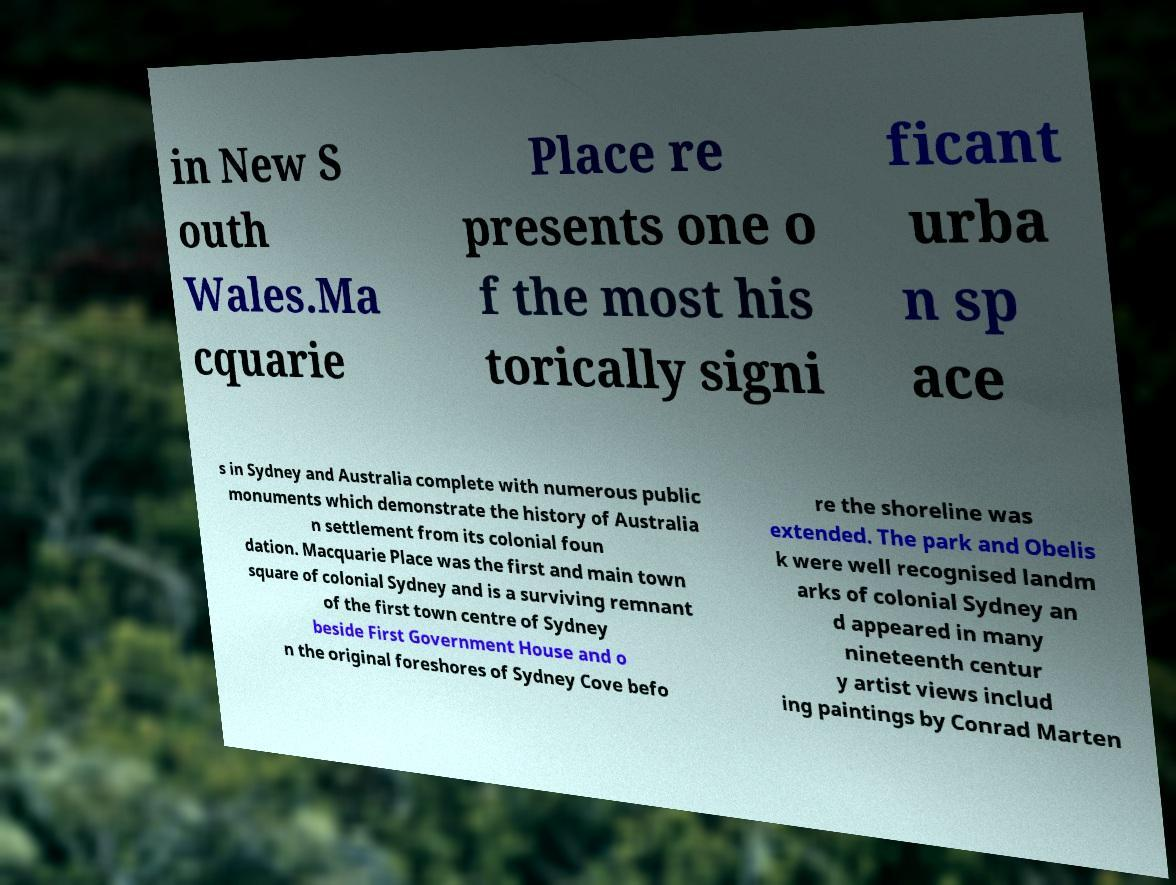There's text embedded in this image that I need extracted. Can you transcribe it verbatim? in New S outh Wales.Ma cquarie Place re presents one o f the most his torically signi ficant urba n sp ace s in Sydney and Australia complete with numerous public monuments which demonstrate the history of Australia n settlement from its colonial foun dation. Macquarie Place was the first and main town square of colonial Sydney and is a surviving remnant of the first town centre of Sydney beside First Government House and o n the original foreshores of Sydney Cove befo re the shoreline was extended. The park and Obelis k were well recognised landm arks of colonial Sydney an d appeared in many nineteenth centur y artist views includ ing paintings by Conrad Marten 